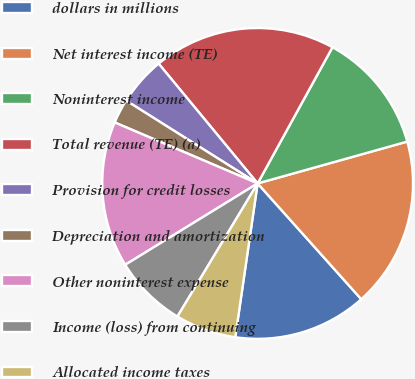Convert chart. <chart><loc_0><loc_0><loc_500><loc_500><pie_chart><fcel>dollars in millions<fcel>Net interest income (TE)<fcel>Noninterest income<fcel>Total revenue (TE) (a)<fcel>Provision for credit losses<fcel>Depreciation and amortization<fcel>Other noninterest expense<fcel>Income (loss) from continuing<fcel>Allocated income taxes<nl><fcel>13.92%<fcel>17.72%<fcel>12.66%<fcel>18.99%<fcel>5.06%<fcel>2.53%<fcel>15.19%<fcel>7.6%<fcel>6.33%<nl></chart> 